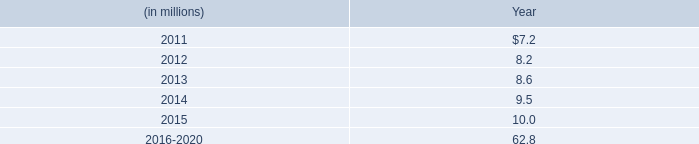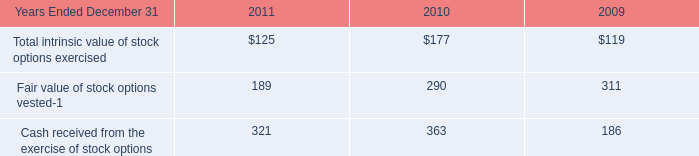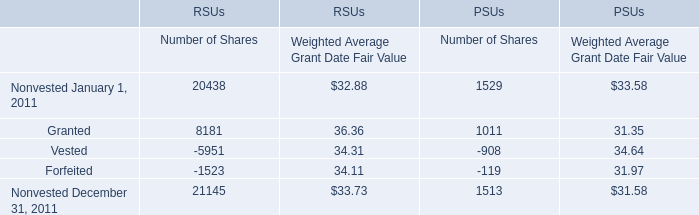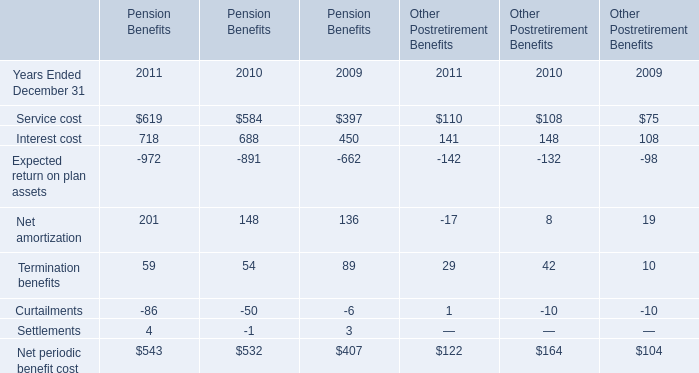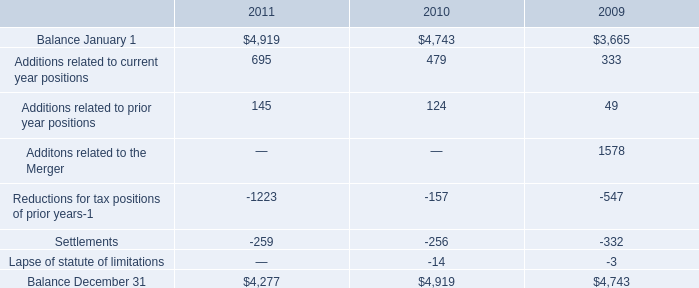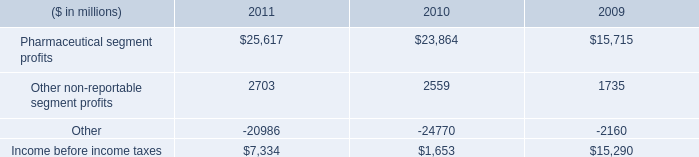assuming an average contribution rate of 3% ( 3 % ) of earnings for defined contribution savings plans , what is the deemed aggregate compensation expense in millions in 2010? 
Computations: (6.3 / 3%)
Answer: 210.0. 